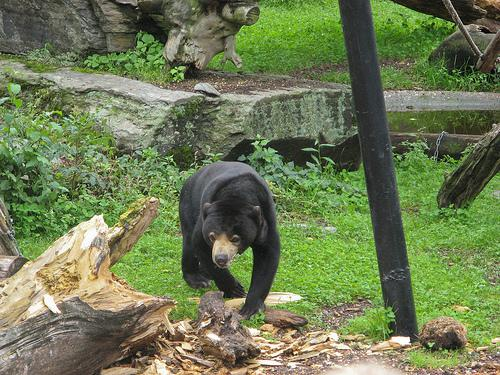Question: what animal is shown?
Choices:
A. Bear.
B. Tiger.
C. Lion.
D. Dog.
Answer with the letter. Answer: A 